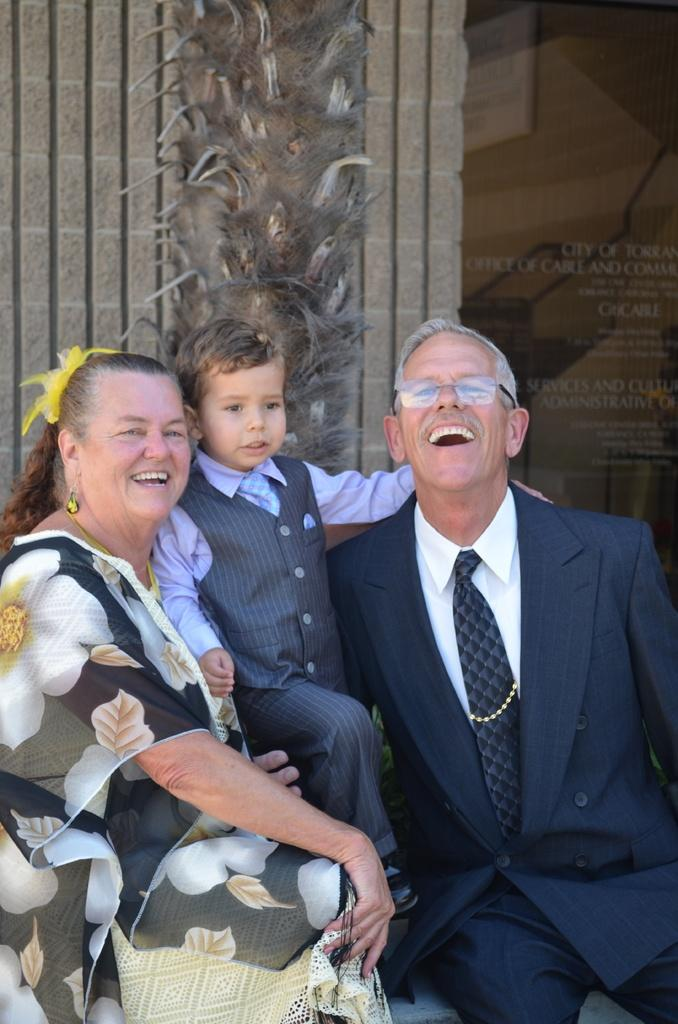How many people are present in the image? There are three people in the image: a man, a woman, and a boy. What can be seen in the background of the image? There is a wall in the background of the image. What is written on the wall? Text is written on the wall. What is the income of the group in the image? There is no information about the income of the people in the image, as it is not mentioned in the provided facts. 